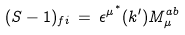<formula> <loc_0><loc_0><loc_500><loc_500>( S - 1 ) _ { f i } \, = \, { { \epsilon } ^ { \mu } } ^ { ^ { * } } ( k ^ { \prime } ) M ^ { a b } _ { \mu }</formula> 